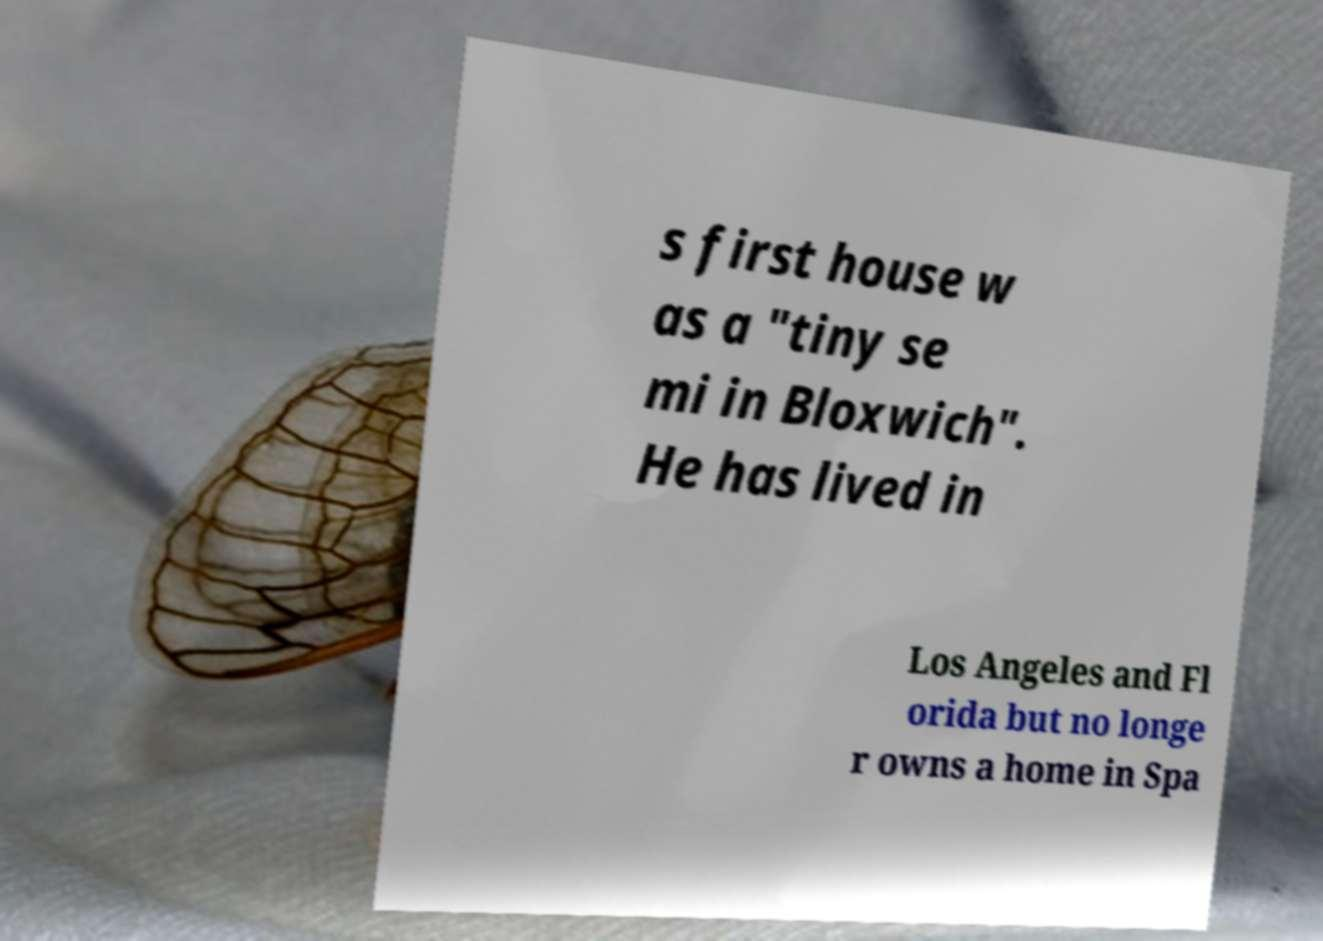There's text embedded in this image that I need extracted. Can you transcribe it verbatim? s first house w as a "tiny se mi in Bloxwich". He has lived in Los Angeles and Fl orida but no longe r owns a home in Spa 